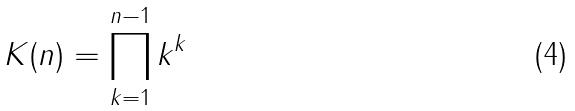Convert formula to latex. <formula><loc_0><loc_0><loc_500><loc_500>K ( n ) = \prod _ { k = 1 } ^ { n - 1 } k ^ { k }</formula> 